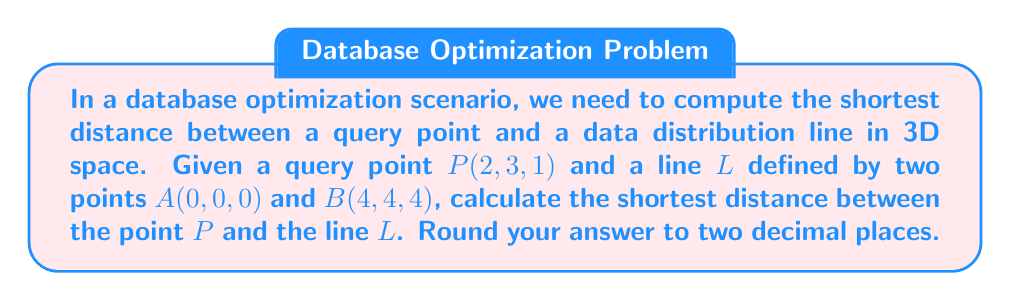Can you answer this question? To find the shortest distance between a point and a line in 3D space, we'll follow these steps:

1) First, we need to find the direction vector of the line $\vec{v}$:
   $$\vec{v} = B - A = (4-0, 4-0, 4-0) = (4, 4, 4)$$

2) Next, we calculate the vector from point $A$ to point $P$:
   $$\vec{AP} = P - A = (2-0, 3-0, 1-0) = (2, 3, 1)$$

3) The shortest distance is the magnitude of the cross product of $\vec{v}$ and $\vec{AP}$, divided by the magnitude of $\vec{v}$:
   $$d = \frac{|\vec{v} \times \vec{AP}|}{|\vec{v}|}$$

4) Let's calculate the cross product $\vec{v} \times \vec{AP}$:
   $$\begin{vmatrix}
   i & j & k \\
   4 & 4 & 4 \\
   2 & 3 & 1
   \end{vmatrix} = (4\cdot1 - 4\cdot3)i - (4\cdot2 - 4\cdot1)j + (4\cdot3 - 4\cdot2)k$$
   $$= -8i - 4j + 4k$$

5) The magnitude of this cross product is:
   $$|\vec{v} \times \vec{AP}| = \sqrt{(-8)^2 + (-4)^2 + 4^2} = \sqrt{64 + 16 + 16} = \sqrt{96} = 4\sqrt{6}$$

6) The magnitude of $\vec{v}$ is:
   $$|\vec{v}| = \sqrt{4^2 + 4^2 + 4^2} = \sqrt{48} = 4\sqrt{3}$$

7) Now we can calculate the distance:
   $$d = \frac{4\sqrt{6}}{4\sqrt{3}} = \frac{\sqrt{6}}{\sqrt{3}} = \sqrt{2} \approx 1.41$$

Rounding to two decimal places, we get 1.41.
Answer: 1.41 